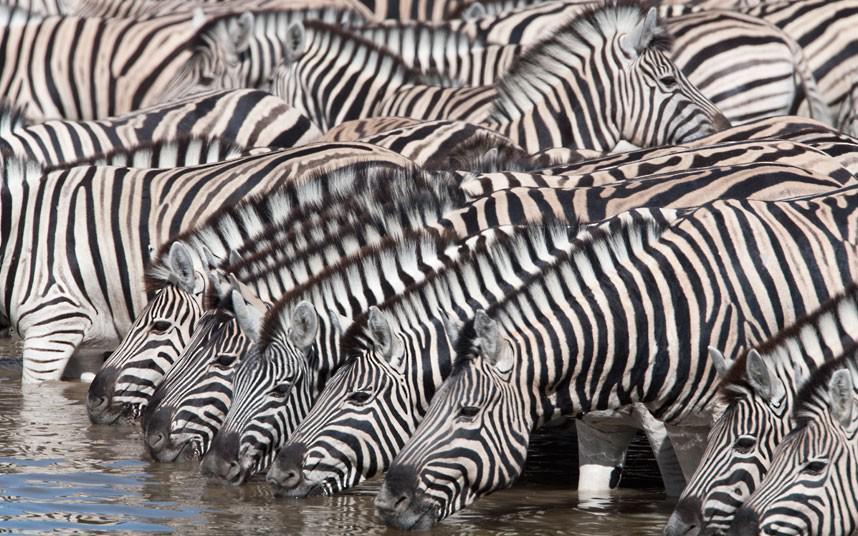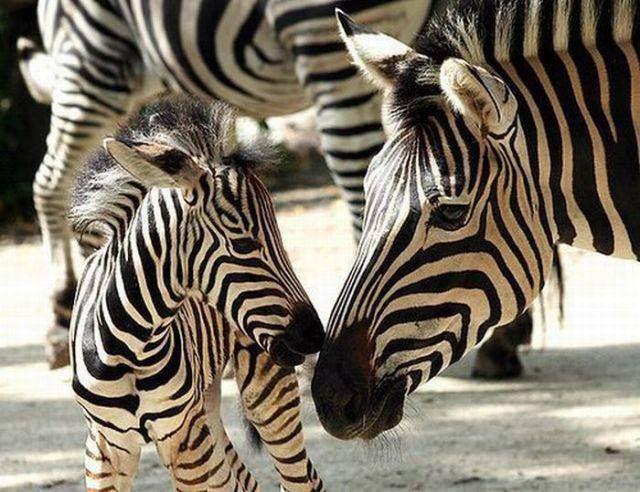The first image is the image on the left, the second image is the image on the right. Evaluate the accuracy of this statement regarding the images: "Both images show zebras standing in water.". Is it true? Answer yes or no. No. The first image is the image on the left, the second image is the image on the right. For the images displayed, is the sentence "More than three zebras can be seen drinking water." factually correct? Answer yes or no. Yes. 